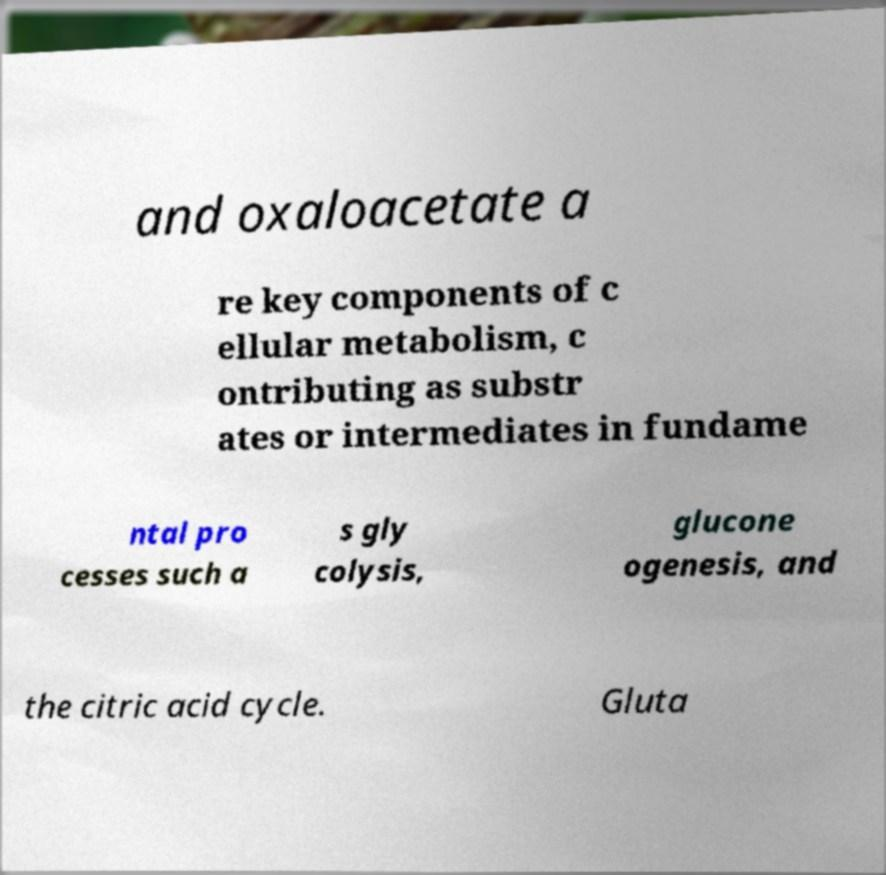Please read and relay the text visible in this image. What does it say? and oxaloacetate a re key components of c ellular metabolism, c ontributing as substr ates or intermediates in fundame ntal pro cesses such a s gly colysis, glucone ogenesis, and the citric acid cycle. Gluta 